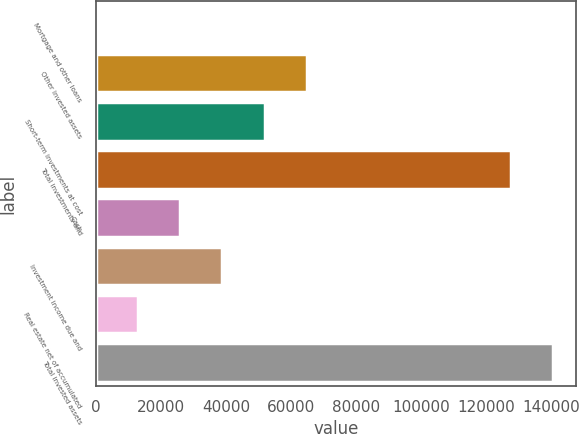Convert chart to OTSL. <chart><loc_0><loc_0><loc_500><loc_500><bar_chart><fcel>Mortgage and other loans<fcel>Other invested assets<fcel>Short-term investments at cost<fcel>Total investments and<fcel>Cash<fcel>Investment income due and<fcel>Real estate net of accumulated<fcel>Total invested assets<nl><fcel>13<fcel>64901<fcel>51923.4<fcel>127512<fcel>25968.2<fcel>38945.8<fcel>12990.6<fcel>140490<nl></chart> 